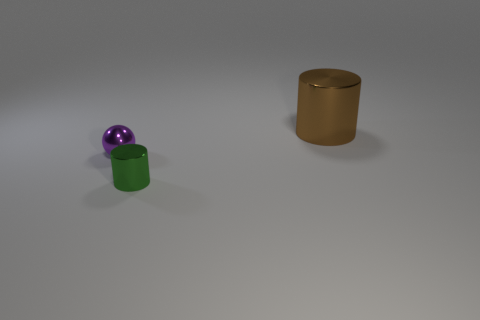There is a purple sphere that is made of the same material as the big brown cylinder; what is its size?
Make the answer very short. Small. There is a metallic cylinder that is in front of the big metal cylinder; is its color the same as the large object?
Offer a very short reply. No. Is the number of green shiny things left of the small green metal cylinder the same as the number of green cylinders on the right side of the large cylinder?
Give a very brief answer. Yes. What color is the metal cylinder in front of the big thing?
Ensure brevity in your answer.  Green. Is the number of small green metallic things behind the tiny cylinder the same as the number of big brown metal objects?
Give a very brief answer. No. How many other things are there of the same shape as the small purple thing?
Offer a terse response. 0. There is a large shiny thing; what number of green cylinders are in front of it?
Ensure brevity in your answer.  1. How big is the metallic object that is both to the right of the metallic sphere and behind the small cylinder?
Keep it short and to the point. Large. Are any big shiny cylinders visible?
Ensure brevity in your answer.  Yes. How many other objects are there of the same size as the purple thing?
Give a very brief answer. 1. 